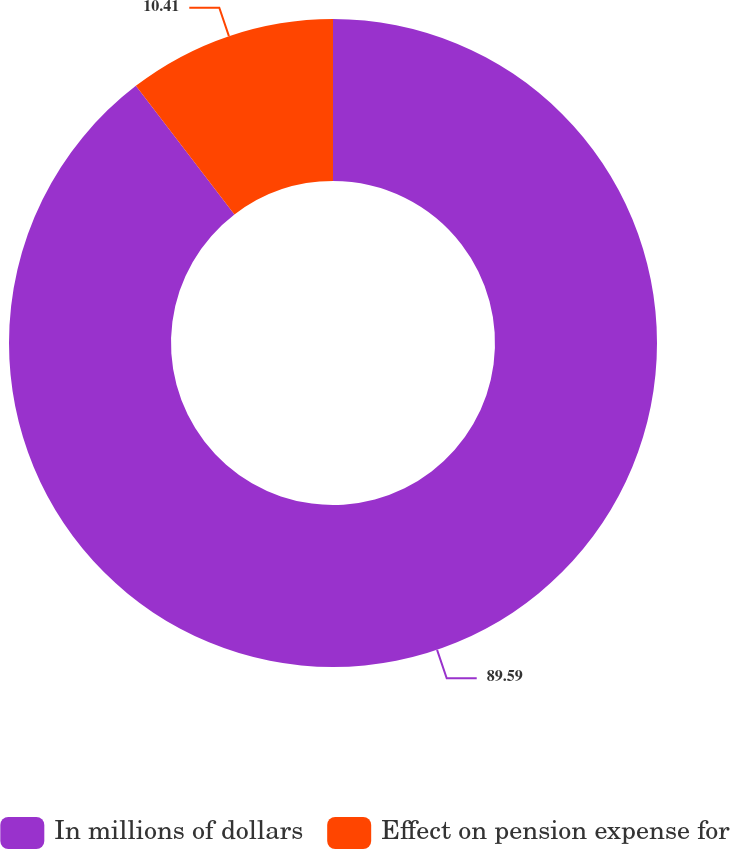Convert chart. <chart><loc_0><loc_0><loc_500><loc_500><pie_chart><fcel>In millions of dollars<fcel>Effect on pension expense for<nl><fcel>89.59%<fcel>10.41%<nl></chart> 